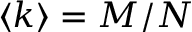<formula> <loc_0><loc_0><loc_500><loc_500>\langle k \rangle = M / N</formula> 